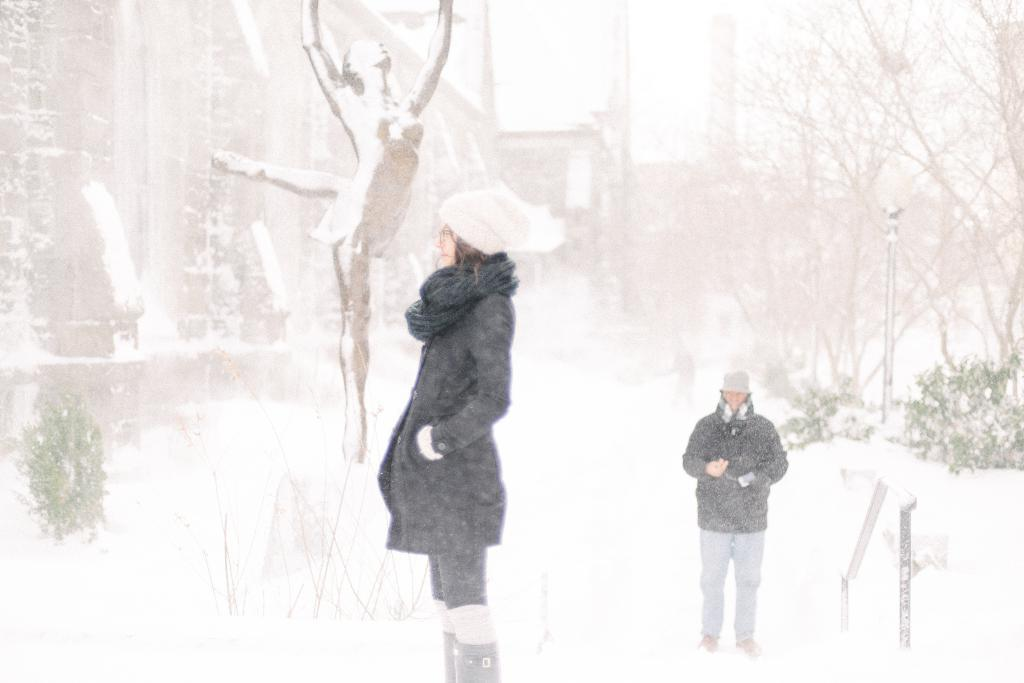How many people are present in the image? There are two people standing in the image. What is the depiction of a woman doing in the image? The information provided does not specify what the woman is doing in the image. What type of natural environment is visible in the image? There is snow visible in the image, which suggests a cold or wintery environment. What type of vegetation can be seen in the image? There are trees and plants in the image. What type of man-made structures are present in the image? There are buildings in the image. What type of vertical structures are present in the image? There are a few poles in the image. Can you see any jellyfish swimming in the seashore in the image? There is no seashore or jellyfish present in the image; it features snow, trees, plants, buildings, and poles. Is there a train visible in the image? There is no train present in the image. 